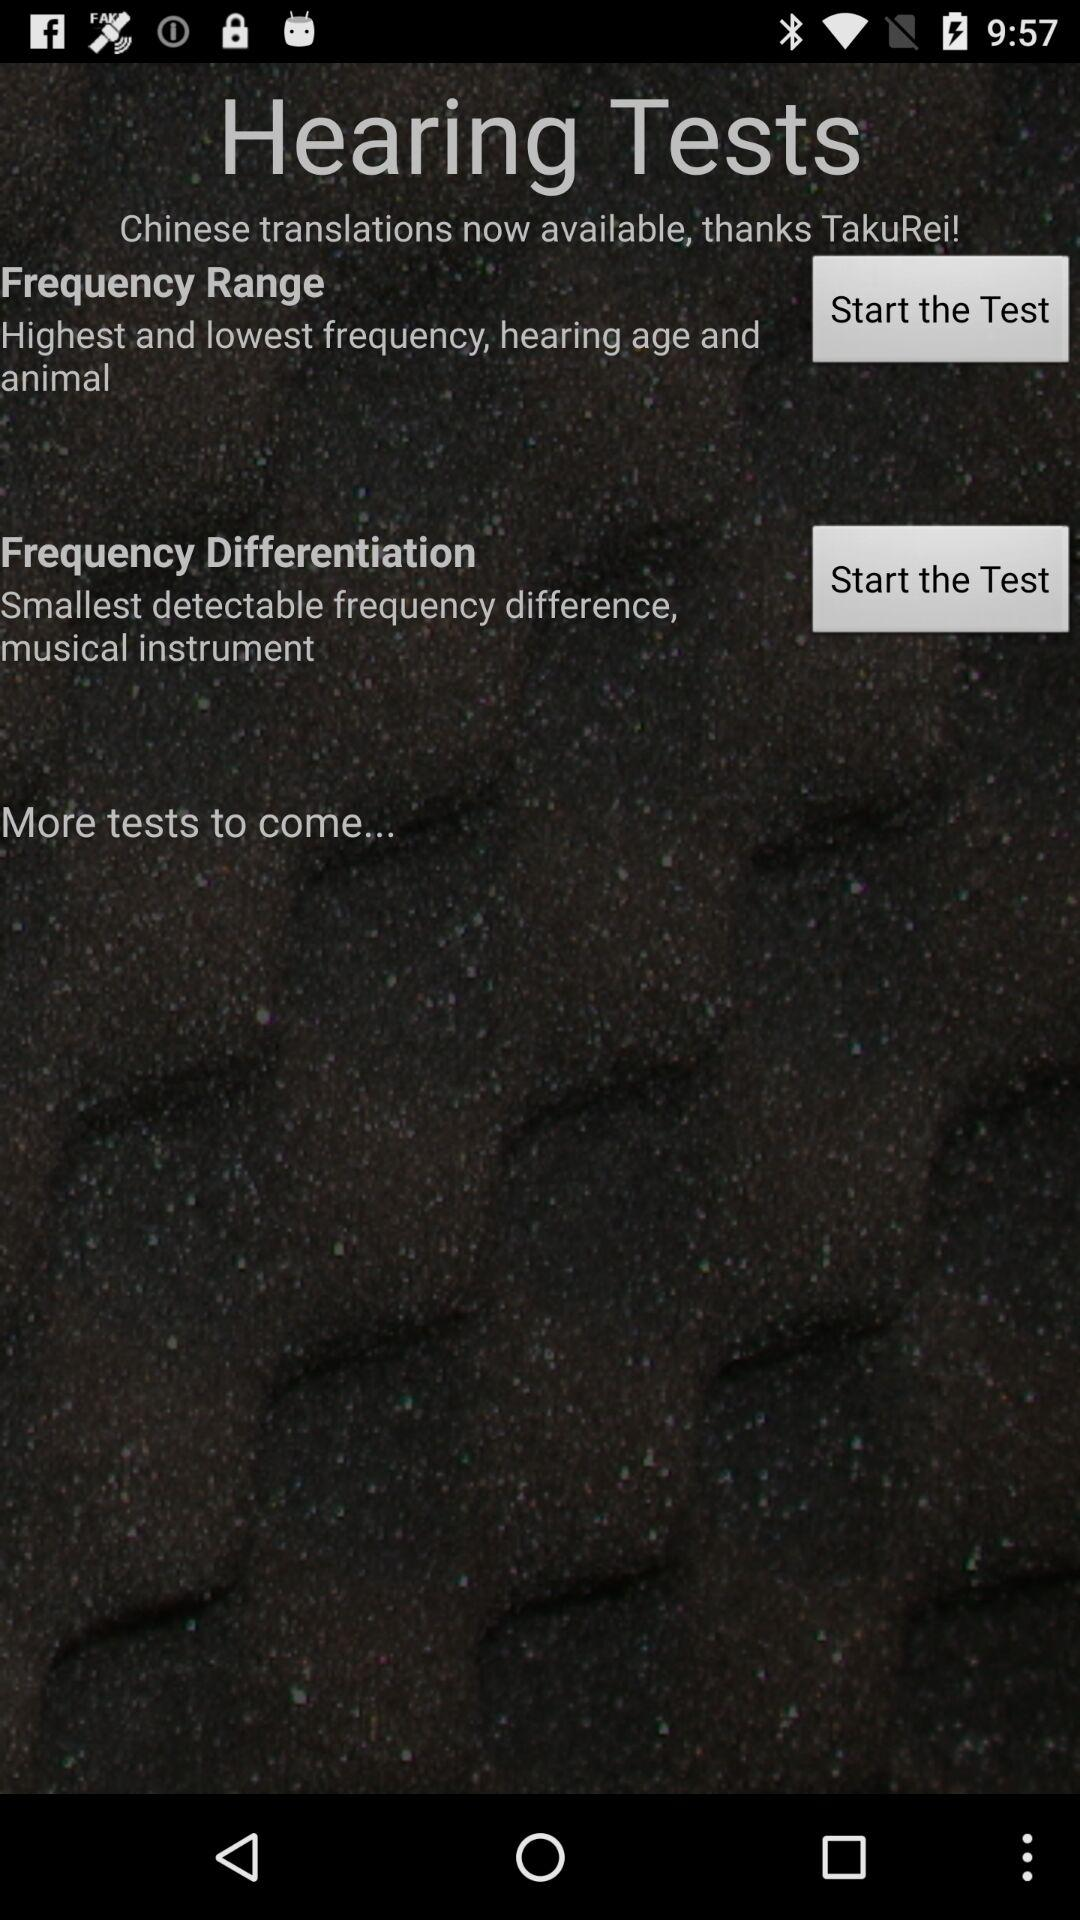How many tests are available on this screen?
Answer the question using a single word or phrase. 2 